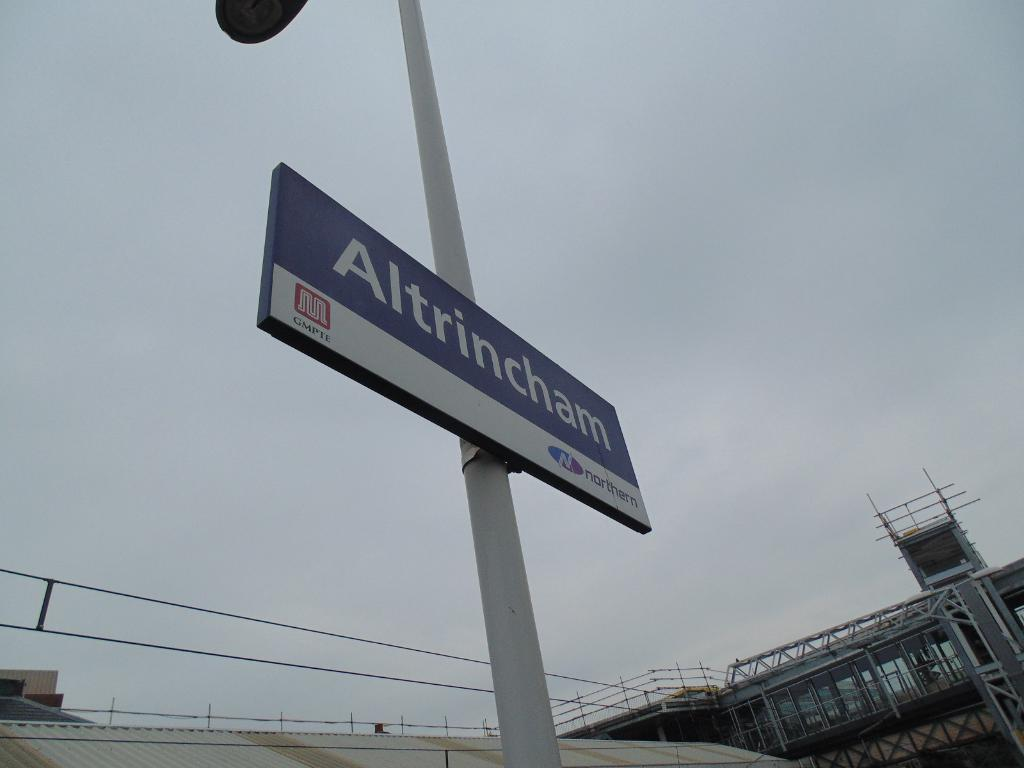What is attached to the pole in the image? There is a board attached to the pole in the image. What can be found on the board? Something is written on the board. What type of structures are visible at the bottom of the image? There are buildings with rods and railings at the bottom of the image. What can be seen in the background of the image? The sky is visible in the background of the image. How does the spoon level the disgust in the image? There is no spoon, level, or disgust present in the image. 